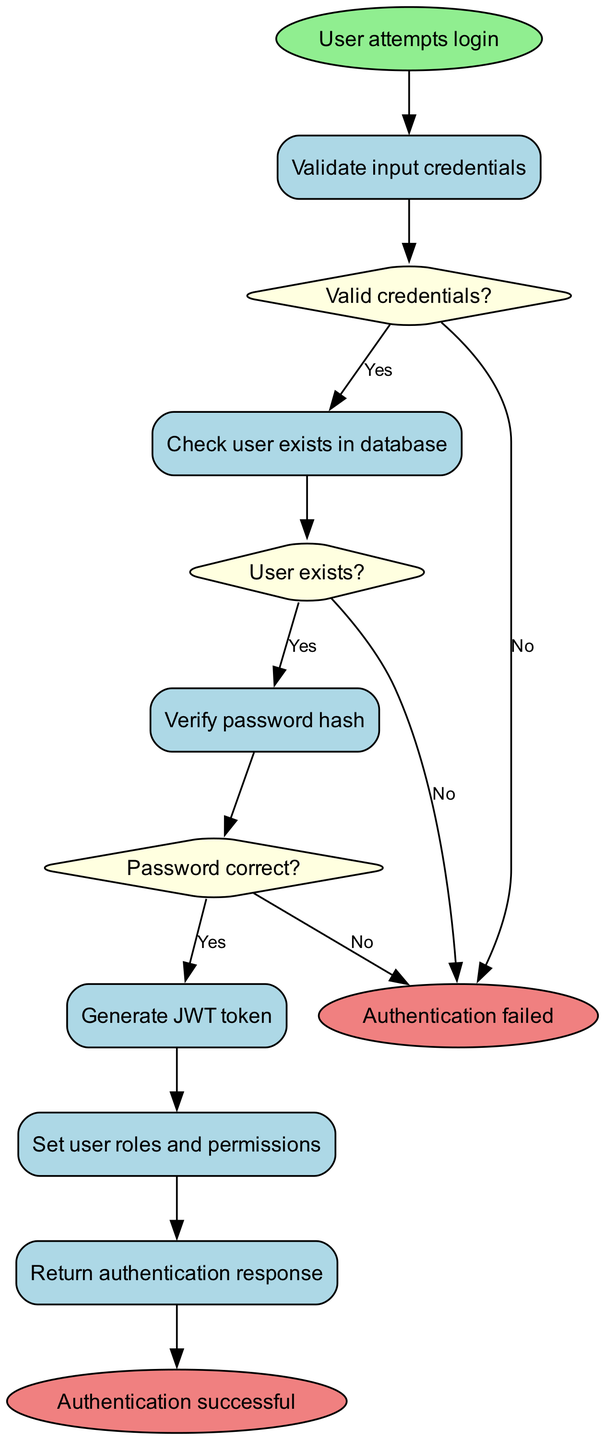What is the starting node of the diagram? The starting node is explicitly labeled as "User attempts login." This is the first point of the user authentication process, indicating the start of the flow.
Answer: User attempts login How many decision nodes are present in the diagram? There are three decision nodes in the diagram: one for validating credentials, one for checking if the user exists, and one for verifying the password. This can be counted directly from the decision section in the diagram.
Answer: 3 What happens if the user credentials are invalid? If the credentials are invalid, the flow goes to the "Return error response" node after the "Valid credentials?" decision node, indicating the unsuccessful authentication attempt.
Answer: Return error response What is the last activity before the successful authentication? The last activity before a successful authentication is "Return authentication response," which indicates the final step following the successful generation of the JWT token.
Answer: Return authentication response What condition must be met for the password verification to proceed? The condition that must be met is "Password correct?" which follows the verification of the entered password against the stored password hash.
Answer: Password correct Which node provides the end result of the authentication process? There are two end nodes providing the result of the authentication process: "Authentication successful" and "Authentication failed." Both signify the outcome of the process flow.
Answer: Authentication successful, Authentication failed What is the flow after generating the JWT token? After generating the JWT token, the flow moves to "Set user roles and permissions" indicating the assignment of user rights before returning the response.
Answer: Set user roles and permissions 